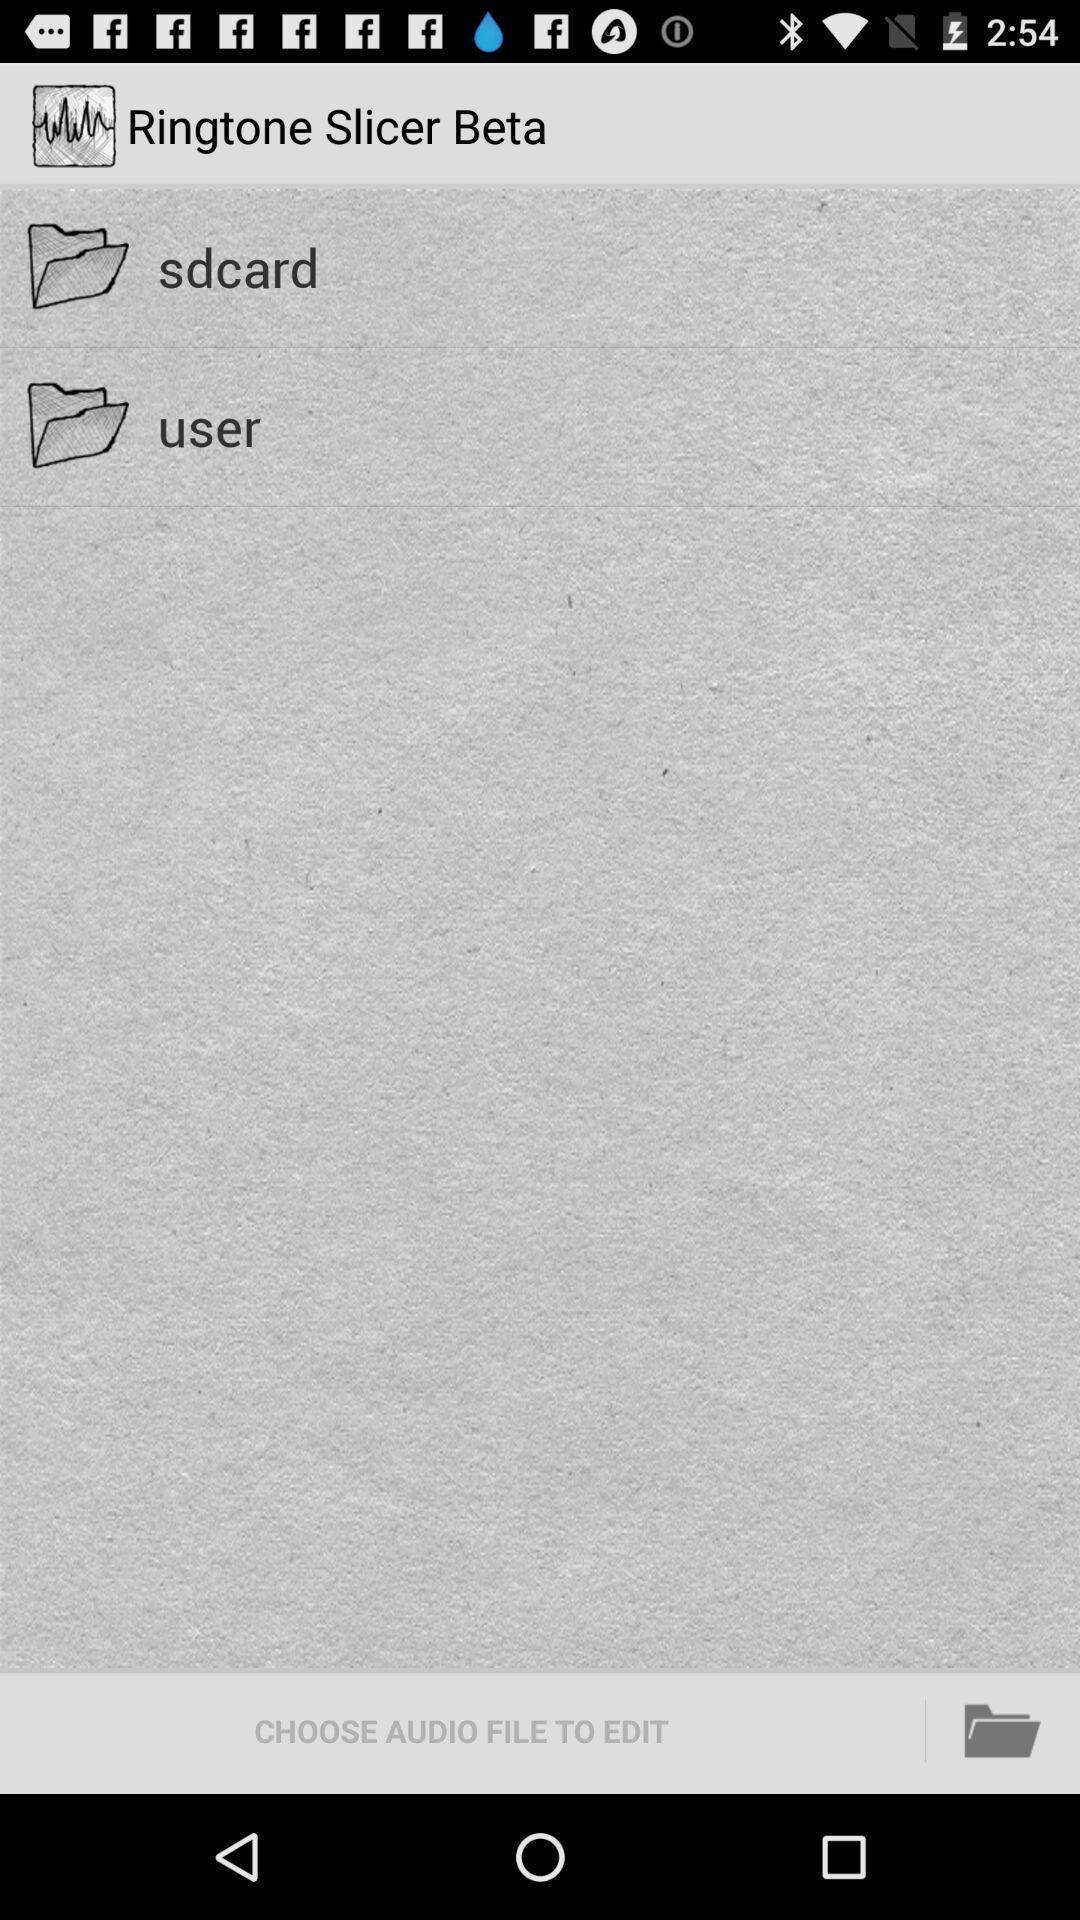What details can you identify in this image? Screen page of a audio editor app. 